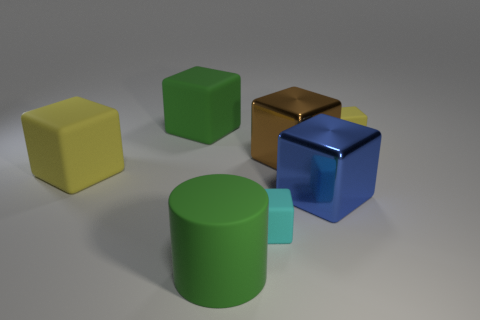There is a big metal cube behind the large blue object; is there a big yellow block that is behind it?
Offer a terse response. No. How many big objects are cyan things or red rubber cubes?
Your answer should be compact. 0. Is there a gray matte block that has the same size as the cyan rubber object?
Make the answer very short. No. What number of rubber objects are either big blue blocks or cyan cylinders?
Offer a very short reply. 0. What is the shape of the large object that is the same color as the cylinder?
Ensure brevity in your answer.  Cube. How many blue matte cylinders are there?
Ensure brevity in your answer.  0. Are the tiny block left of the brown object and the brown cube that is behind the blue cube made of the same material?
Keep it short and to the point. No. There is a cylinder that is the same material as the cyan cube; what size is it?
Ensure brevity in your answer.  Large. The yellow object behind the big brown metal object has what shape?
Ensure brevity in your answer.  Cube. Do the small block behind the cyan matte block and the big rubber thing that is on the left side of the green matte cube have the same color?
Your answer should be very brief. Yes. 